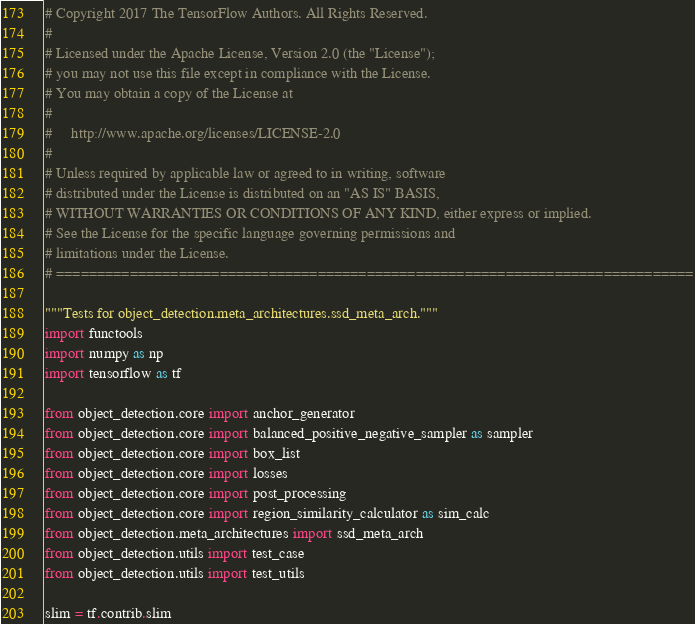<code> <loc_0><loc_0><loc_500><loc_500><_Python_># Copyright 2017 The TensorFlow Authors. All Rights Reserved.
#
# Licensed under the Apache License, Version 2.0 (the "License");
# you may not use this file except in compliance with the License.
# You may obtain a copy of the License at
#
#     http://www.apache.org/licenses/LICENSE-2.0
#
# Unless required by applicable law or agreed to in writing, software
# distributed under the License is distributed on an "AS IS" BASIS,
# WITHOUT WARRANTIES OR CONDITIONS OF ANY KIND, either express or implied.
# See the License for the specific language governing permissions and
# limitations under the License.
# ==============================================================================

"""Tests for object_detection.meta_architectures.ssd_meta_arch."""
import functools
import numpy as np
import tensorflow as tf

from object_detection.core import anchor_generator
from object_detection.core import balanced_positive_negative_sampler as sampler
from object_detection.core import box_list
from object_detection.core import losses
from object_detection.core import post_processing
from object_detection.core import region_similarity_calculator as sim_calc
from object_detection.meta_architectures import ssd_meta_arch
from object_detection.utils import test_case
from object_detection.utils import test_utils

slim = tf.contrib.slim

</code> 